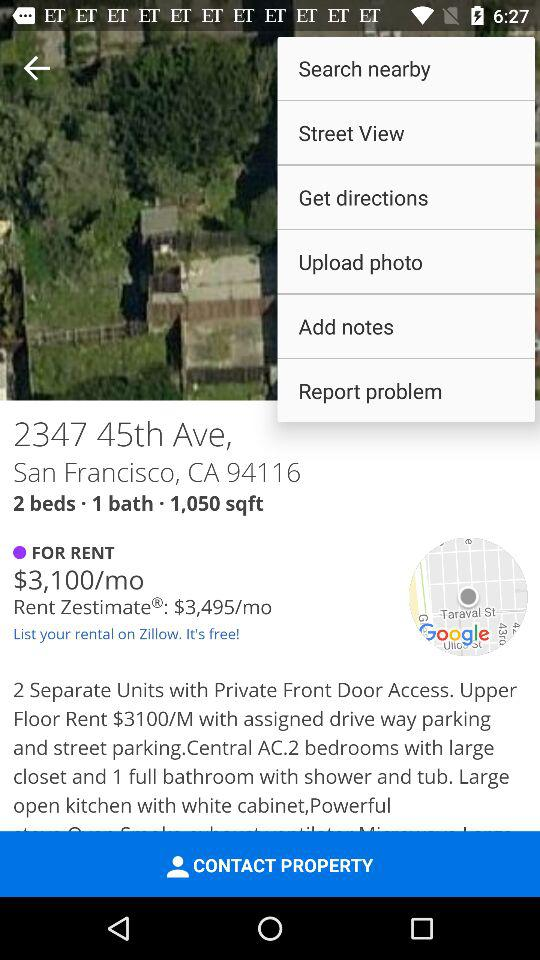What is the address? The address is 2347 45th Ave., San Francisco, CA 94116. 